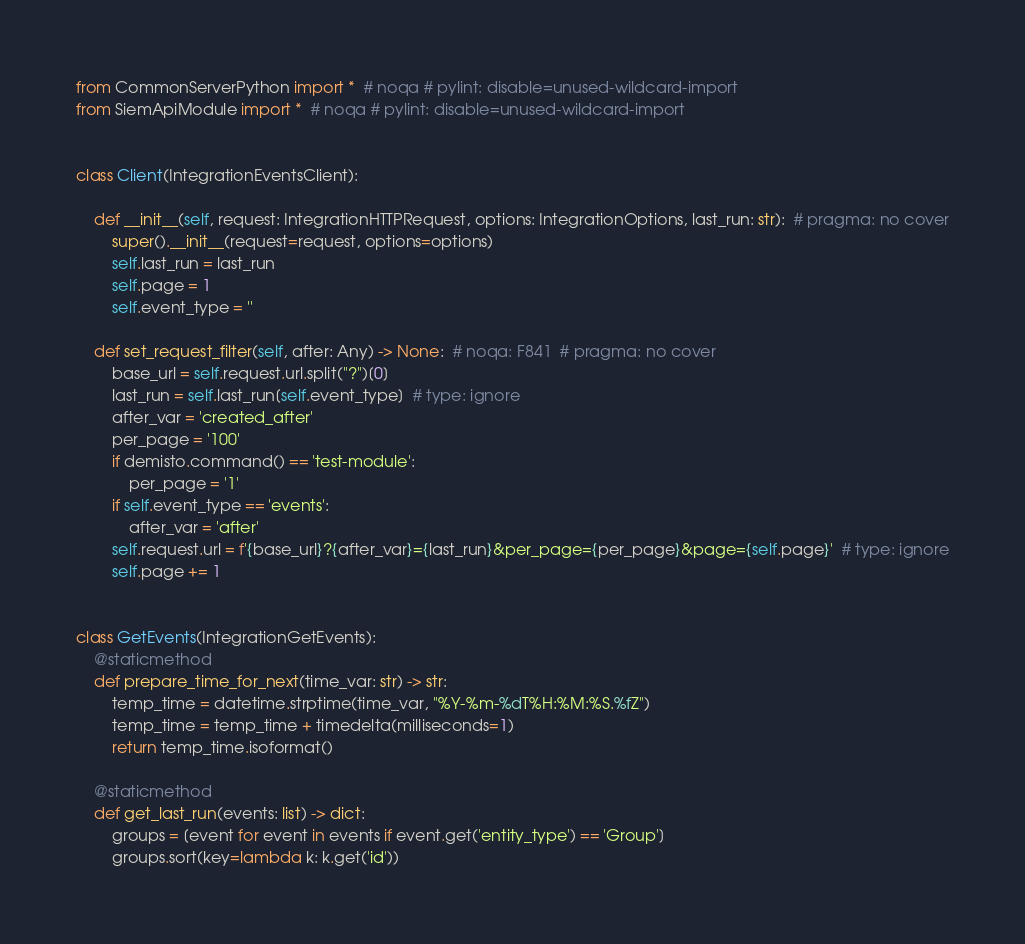<code> <loc_0><loc_0><loc_500><loc_500><_Python_>from CommonServerPython import *  # noqa # pylint: disable=unused-wildcard-import
from SiemApiModule import *  # noqa # pylint: disable=unused-wildcard-import


class Client(IntegrationEventsClient):

    def __init__(self, request: IntegrationHTTPRequest, options: IntegrationOptions, last_run: str):  # pragma: no cover
        super().__init__(request=request, options=options)
        self.last_run = last_run
        self.page = 1
        self.event_type = ''

    def set_request_filter(self, after: Any) -> None:  # noqa: F841  # pragma: no cover
        base_url = self.request.url.split("?")[0]
        last_run = self.last_run[self.event_type]  # type: ignore
        after_var = 'created_after'
        per_page = '100'
        if demisto.command() == 'test-module':
            per_page = '1'
        if self.event_type == 'events':
            after_var = 'after'
        self.request.url = f'{base_url}?{after_var}={last_run}&per_page={per_page}&page={self.page}'  # type: ignore
        self.page += 1


class GetEvents(IntegrationGetEvents):
    @staticmethod
    def prepare_time_for_next(time_var: str) -> str:
        temp_time = datetime.strptime(time_var, "%Y-%m-%dT%H:%M:%S.%fZ")
        temp_time = temp_time + timedelta(milliseconds=1)
        return temp_time.isoformat()

    @staticmethod
    def get_last_run(events: list) -> dict:
        groups = [event for event in events if event.get('entity_type') == 'Group']
        groups.sort(key=lambda k: k.get('id'))</code> 